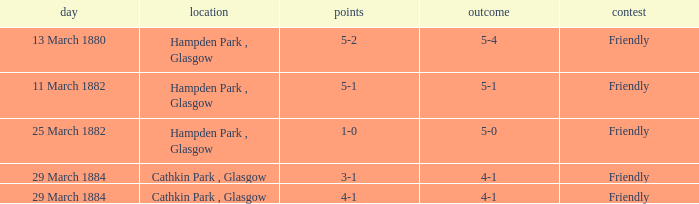Which competition had a 4-1 result, and a score of 4-1? Friendly. 